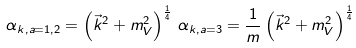<formula> <loc_0><loc_0><loc_500><loc_500>\alpha _ { k , a = 1 , 2 } = \left ( \vec { k } ^ { 2 } + m _ { V } ^ { 2 } \right ) ^ { \frac { 1 } { 4 } } \, \alpha _ { k , a = 3 } = \frac { 1 } { m } \left ( \vec { k } ^ { 2 } + m _ { V } ^ { 2 } \right ) ^ { \frac { 1 } { 4 } }</formula> 